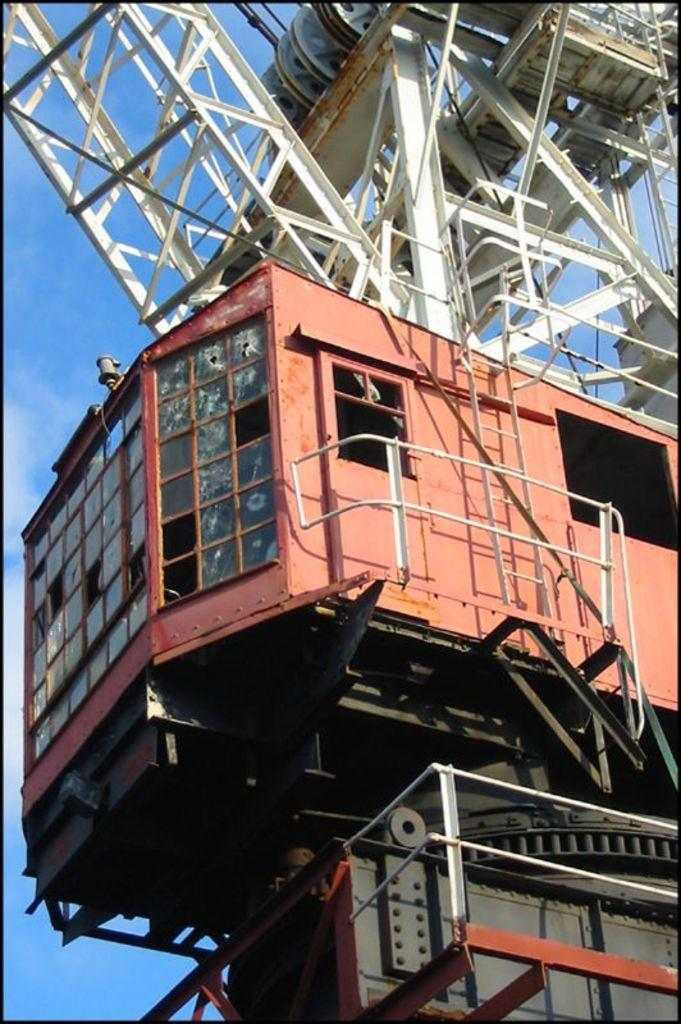What is the main subject in the center of the image? There is a vehicle in the center of the image. What structures can be seen in the image? There are towers in the image. What are the tall, thin objects in the image? There are poles in the image. What else can be seen in the image besides the vehicle, towers, and poles? There are objects in the image. What is visible in the background of the image? The sky is visible in the background of the image. What type of brass instrument is being played on the stage in the image? There is no brass instrument or stage present in the image; it features a vehicle, towers, poles, and other objects. What happens to the vehicle when it smashes into the towers in the image? There is no indication in the image that the vehicle is smashing into the towers or any other objects. 